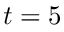Convert formula to latex. <formula><loc_0><loc_0><loc_500><loc_500>t = 5</formula> 